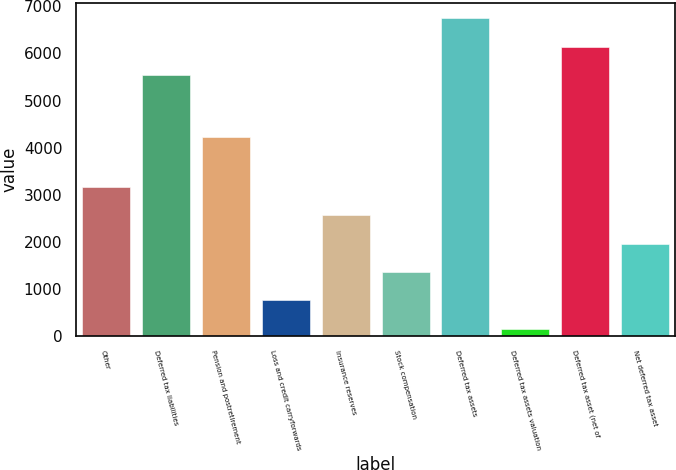Convert chart. <chart><loc_0><loc_0><loc_500><loc_500><bar_chart><fcel>Other<fcel>Deferred tax liabilities<fcel>Pension and postretirement<fcel>Loss and credit carryforwards<fcel>Insurance reserves<fcel>Stock compensation<fcel>Deferred tax assets<fcel>Deferred tax assets valuation<fcel>Deferred tax asset (net of<fcel>Net deferred tax asset<nl><fcel>3167.5<fcel>5538<fcel>4236<fcel>760.7<fcel>2565.8<fcel>1362.4<fcel>6741.4<fcel>159<fcel>6139.7<fcel>1964.1<nl></chart> 